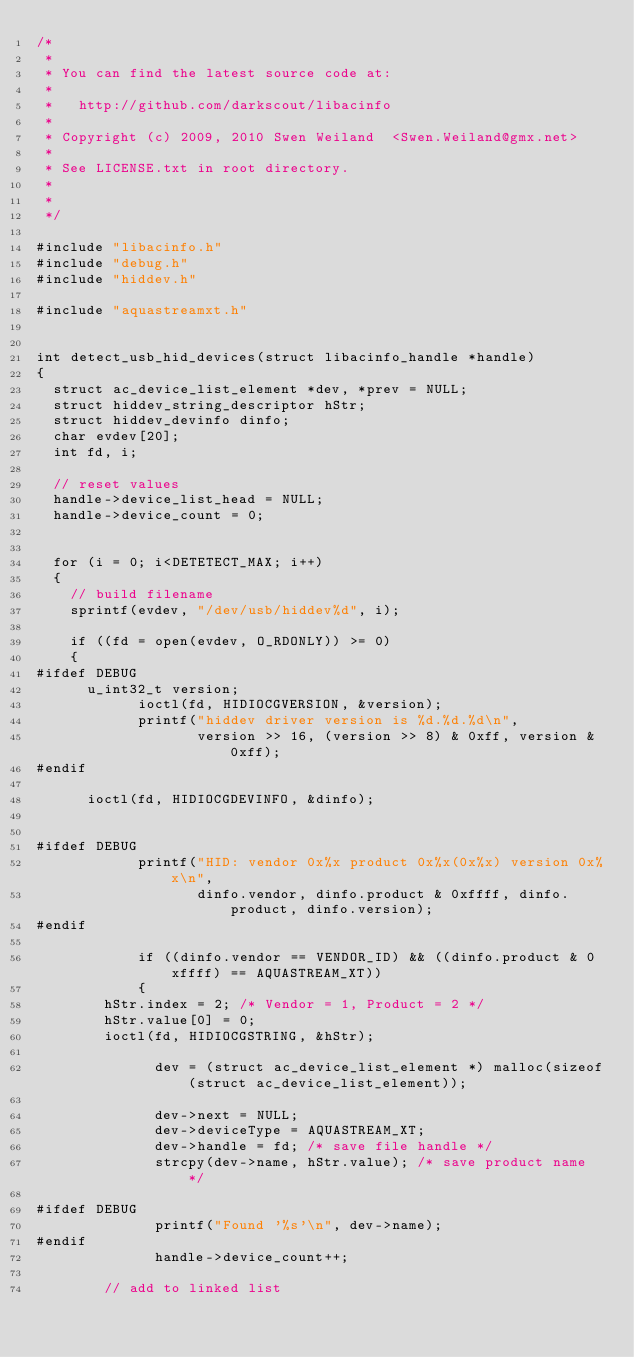Convert code to text. <code><loc_0><loc_0><loc_500><loc_500><_C_>/*
 *
 * You can find the latest source code at:
 * 
 *   http://github.com/darkscout/libacinfo
 *
 * Copyright (c) 2009, 2010 Swen Weiland  <Swen.Weiland@gmx.net>
 *
 * See LICENSE.txt in root directory.
 *
 *
 */

#include "libacinfo.h"
#include "debug.h"
#include "hiddev.h"

#include "aquastreamxt.h"


int detect_usb_hid_devices(struct libacinfo_handle *handle) 
{
	struct ac_device_list_element *dev, *prev = NULL;
	struct hiddev_string_descriptor hStr;
	struct hiddev_devinfo dinfo;
	char evdev[20];
	int fd, i;
	
	// reset values
	handle->device_list_head = NULL;
	handle->device_count = 0;


	for (i = 0; i<DETETECT_MAX; i++)
	{
		// build filename
		sprintf(evdev, "/dev/usb/hiddev%d", i);
		
		if ((fd = open(evdev, O_RDONLY)) >= 0)
		{
#ifdef DEBUG
			u_int32_t version;
		        ioctl(fd, HIDIOCGVERSION, &version);
		        printf("hiddev driver version is %d.%d.%d\n",
		               version >> 16, (version >> 8) & 0xff, version & 0xff);
#endif

		 	ioctl(fd, HIDIOCGDEVINFO, &dinfo);
		

#ifdef DEBUG
		        printf("HID: vendor 0x%x product 0x%x(0x%x) version 0x%x\n",
		               dinfo.vendor, dinfo.product & 0xffff, dinfo.product, dinfo.version);
#endif

	        	if ((dinfo.vendor == VENDOR_ID) && ((dinfo.product & 0xffff) == AQUASTREAM_XT))
	        	{
				hStr.index = 2; /* Vendor = 1, Product = 2 */
				hStr.value[0] = 0;
				ioctl(fd, HIDIOCGSTRING, &hStr);

		        	dev = (struct ac_device_list_element *) malloc(sizeof(struct ac_device_list_element));

		        	dev->next = NULL;
		        	dev->deviceType = AQUASTREAM_XT;
		        	dev->handle = fd; /* save file handle */
		        	strcpy(dev->name, hStr.value); /* save product name */

#ifdef DEBUG
		        	printf("Found '%s'\n", dev->name);
#endif		       
		        	handle->device_count++;

				// add to linked list </code> 